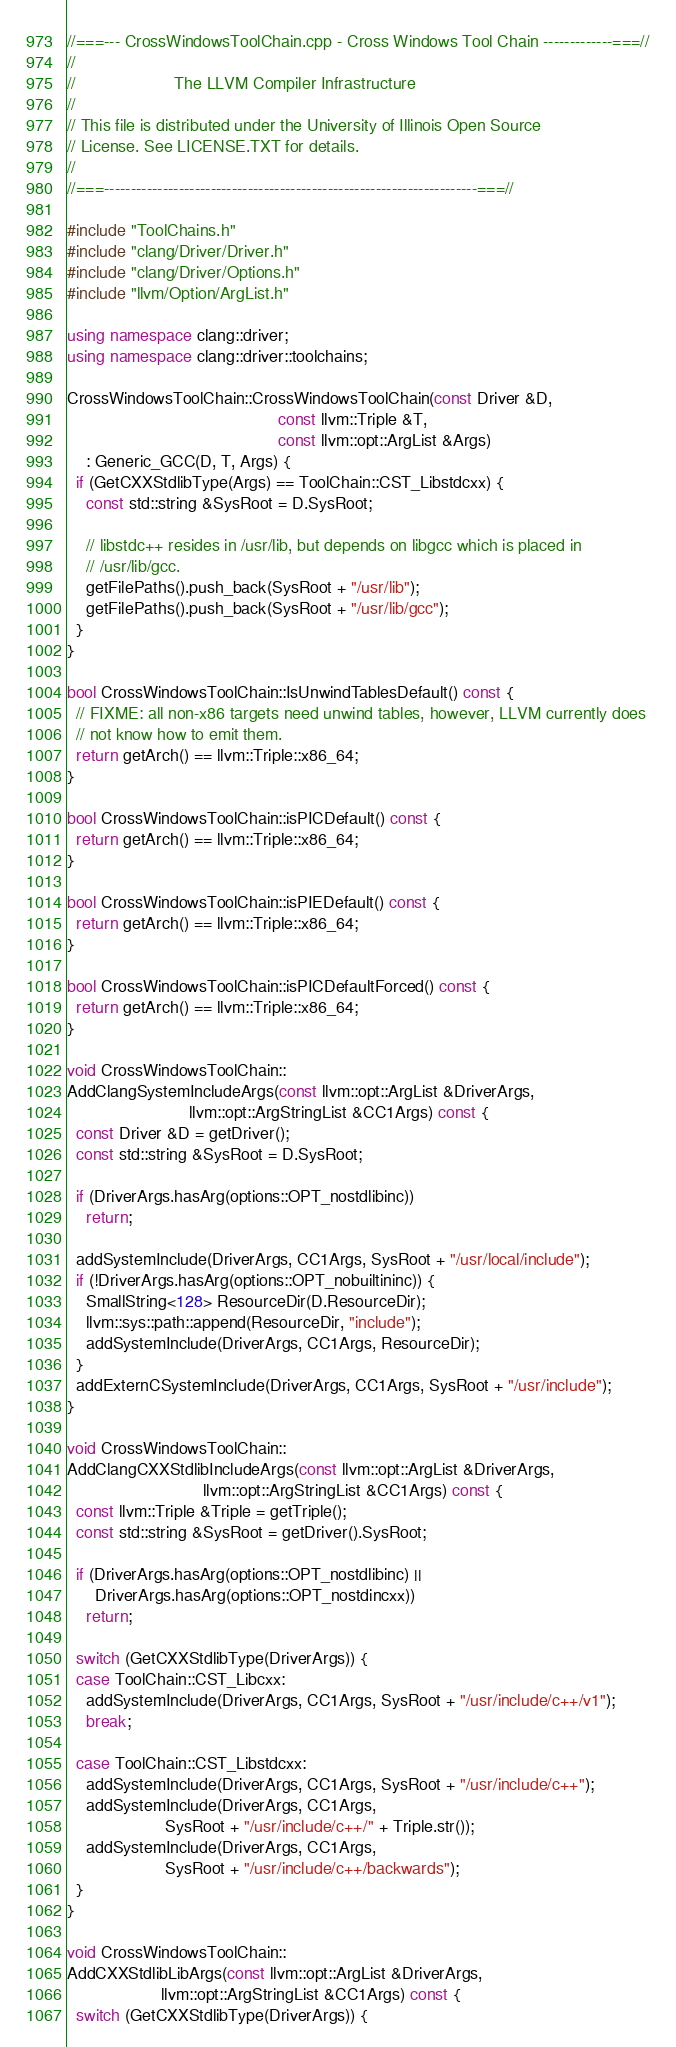<code> <loc_0><loc_0><loc_500><loc_500><_C++_>//===--- CrossWindowsToolChain.cpp - Cross Windows Tool Chain -------------===//
//
//                     The LLVM Compiler Infrastructure
//
// This file is distributed under the University of Illinois Open Source
// License. See LICENSE.TXT for details.
//
//===----------------------------------------------------------------------===//

#include "ToolChains.h"
#include "clang/Driver/Driver.h"
#include "clang/Driver/Options.h"
#include "llvm/Option/ArgList.h"

using namespace clang::driver;
using namespace clang::driver::toolchains;

CrossWindowsToolChain::CrossWindowsToolChain(const Driver &D,
                                             const llvm::Triple &T,
                                             const llvm::opt::ArgList &Args)
    : Generic_GCC(D, T, Args) {
  if (GetCXXStdlibType(Args) == ToolChain::CST_Libstdcxx) {
    const std::string &SysRoot = D.SysRoot;

    // libstdc++ resides in /usr/lib, but depends on libgcc which is placed in
    // /usr/lib/gcc.
    getFilePaths().push_back(SysRoot + "/usr/lib");
    getFilePaths().push_back(SysRoot + "/usr/lib/gcc");
  }
}

bool CrossWindowsToolChain::IsUnwindTablesDefault() const {
  // FIXME: all non-x86 targets need unwind tables, however, LLVM currently does
  // not know how to emit them.
  return getArch() == llvm::Triple::x86_64;
}

bool CrossWindowsToolChain::isPICDefault() const {
  return getArch() == llvm::Triple::x86_64;
}

bool CrossWindowsToolChain::isPIEDefault() const {
  return getArch() == llvm::Triple::x86_64;
}

bool CrossWindowsToolChain::isPICDefaultForced() const {
  return getArch() == llvm::Triple::x86_64;
}

void CrossWindowsToolChain::
AddClangSystemIncludeArgs(const llvm::opt::ArgList &DriverArgs,
                          llvm::opt::ArgStringList &CC1Args) const {
  const Driver &D = getDriver();
  const std::string &SysRoot = D.SysRoot;

  if (DriverArgs.hasArg(options::OPT_nostdlibinc))
    return;

  addSystemInclude(DriverArgs, CC1Args, SysRoot + "/usr/local/include");
  if (!DriverArgs.hasArg(options::OPT_nobuiltininc)) {
    SmallString<128> ResourceDir(D.ResourceDir);
    llvm::sys::path::append(ResourceDir, "include");
    addSystemInclude(DriverArgs, CC1Args, ResourceDir);
  }
  addExternCSystemInclude(DriverArgs, CC1Args, SysRoot + "/usr/include");
}

void CrossWindowsToolChain::
AddClangCXXStdlibIncludeArgs(const llvm::opt::ArgList &DriverArgs,
                             llvm::opt::ArgStringList &CC1Args) const {
  const llvm::Triple &Triple = getTriple();
  const std::string &SysRoot = getDriver().SysRoot;

  if (DriverArgs.hasArg(options::OPT_nostdlibinc) ||
      DriverArgs.hasArg(options::OPT_nostdincxx))
    return;

  switch (GetCXXStdlibType(DriverArgs)) {
  case ToolChain::CST_Libcxx:
    addSystemInclude(DriverArgs, CC1Args, SysRoot + "/usr/include/c++/v1");
    break;

  case ToolChain::CST_Libstdcxx:
    addSystemInclude(DriverArgs, CC1Args, SysRoot + "/usr/include/c++");
    addSystemInclude(DriverArgs, CC1Args,
                     SysRoot + "/usr/include/c++/" + Triple.str());
    addSystemInclude(DriverArgs, CC1Args,
                     SysRoot + "/usr/include/c++/backwards");
  }
}

void CrossWindowsToolChain::
AddCXXStdlibLibArgs(const llvm::opt::ArgList &DriverArgs,
                    llvm::opt::ArgStringList &CC1Args) const {
  switch (GetCXXStdlibType(DriverArgs)) {</code> 